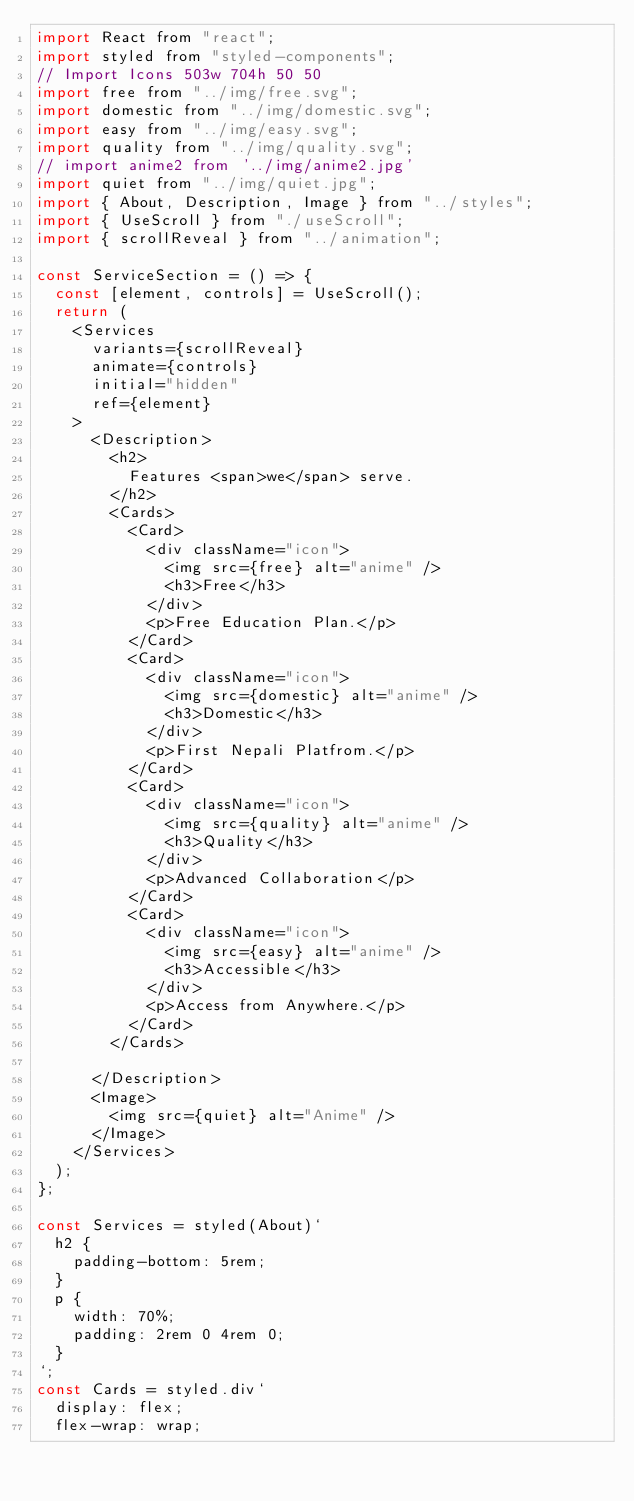Convert code to text. <code><loc_0><loc_0><loc_500><loc_500><_JavaScript_>import React from "react";
import styled from "styled-components";
// Import Icons 503w 704h 50 50
import free from "../img/free.svg";
import domestic from "../img/domestic.svg";
import easy from "../img/easy.svg";
import quality from "../img/quality.svg";
// import anime2 from '../img/anime2.jpg'
import quiet from "../img/quiet.jpg";
import { About, Description, Image } from "../styles";
import { UseScroll } from "./useScroll";
import { scrollReveal } from "../animation";

const ServiceSection = () => {
  const [element, controls] = UseScroll();
  return (
    <Services
      variants={scrollReveal}
      animate={controls}
      initial="hidden"
      ref={element}
    >
      <Description>
        <h2>
          Features <span>we</span> serve.
        </h2>
        <Cards>
          <Card>
            <div className="icon">
              <img src={free} alt="anime" />
              <h3>Free</h3>
            </div>
            <p>Free Education Plan.</p>
          </Card>
          <Card>
            <div className="icon">
              <img src={domestic} alt="anime" />
              <h3>Domestic</h3>
            </div>
            <p>First Nepali Platfrom.</p>
          </Card>
          <Card>
            <div className="icon">
              <img src={quality} alt="anime" />
              <h3>Quality</h3>
            </div>
            <p>Advanced Collaboration</p>
          </Card>
          <Card>
            <div className="icon">
              <img src={easy} alt="anime" />
              <h3>Accessible</h3>
            </div>
            <p>Access from Anywhere.</p>
          </Card>
        </Cards>

      </Description>
      <Image>
        <img src={quiet} alt="Anime" />
      </Image>
    </Services>
  );
};

const Services = styled(About)`
  h2 {
    padding-bottom: 5rem;
  }
  p {
    width: 70%;
    padding: 2rem 0 4rem 0;
  }
`;
const Cards = styled.div`
  display: flex;
  flex-wrap: wrap;</code> 